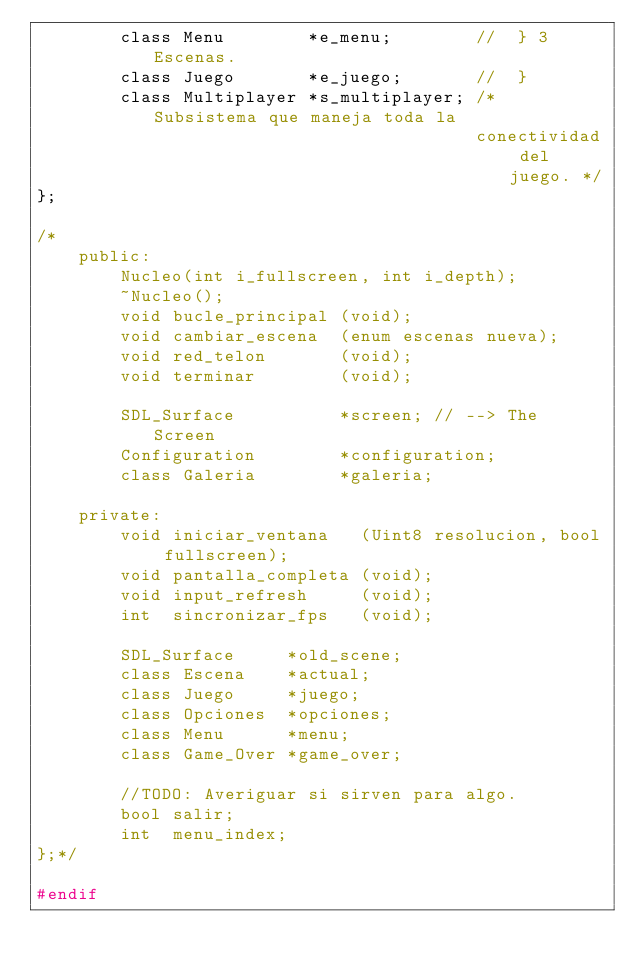<code> <loc_0><loc_0><loc_500><loc_500><_C_>  		class Menu        *e_menu;        //  } 3 Escenas.
		class Juego       *e_juego;       //  }
		class Multiplayer *s_multiplayer; /* Subsistema que maneja toda la
                                          conectividad del juego. */
};

/*
    public:
		Nucleo(int i_fullscreen, int i_depth);
		~Nucleo();
		void bucle_principal (void);
		void cambiar_escena  (enum escenas nueva);
		void red_telon       (void);
		void terminar        (void);

        SDL_Surface          *screen; // --> The Screen
        Configuration        *configuration;
		class Galeria        *galeria;

    private:
		void iniciar_ventana   (Uint8 resolucion, bool fullscreen);
		void pantalla_completa (void);
		void input_refresh     (void);
		int  sincronizar_fps   (void);

        SDL_Surface     *old_scene;
  		class Escena    *actual;
		class Juego     *juego;
		class Opciones  *opciones;
		class Menu      *menu;
		class Game_Over *game_over;

        //TODO: Averiguar si sirven para algo.
        bool salir;
		int  menu_index;
};*/

#endif
</code> 